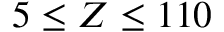Convert formula to latex. <formula><loc_0><loc_0><loc_500><loc_500>5 \leq Z \leq 1 1 0</formula> 